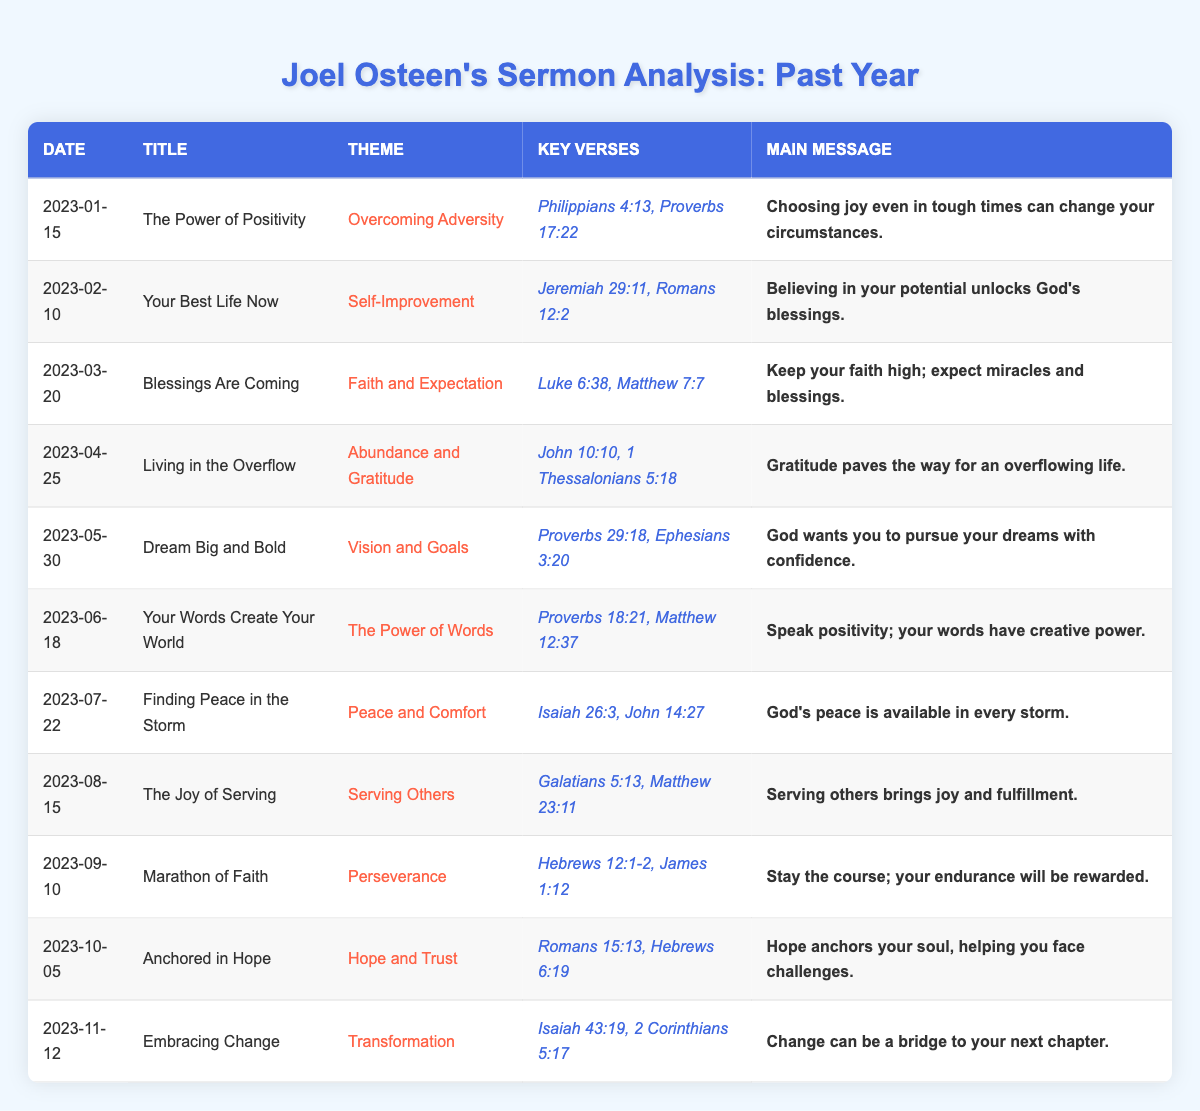What is the theme of the sermon titled "Finding Peace in the Storm"? The title "Finding Peace in the Storm" corresponds to the theme "Peace and Comfort" as listed in the table. To find the theme, I simply looked for the row that contains the sermon title in question.
Answer: Peace and Comfort How many sermons are focused on the theme of "Faith and Expectation"? There is one sermon that specifically addresses the theme "Faith and Expectation", which is titled "Blessings Are Coming." I checked each theme in the table and counted the occurrences.
Answer: 1 What are the key verses for the sermon "Dream Big and Bold"? The sermon "Dream Big and Bold" lists its key verses as "Proverbs 29:18, Ephesians 3:20." I looked at the row corresponding to this title and read the key verses directly.
Answer: Proverbs 29:18, Ephesians 3:20 Is there a sermon that addresses "Serving Others" and what is its main message? Yes, there is a sermon titled "The Joy of Serving" that addresses "Serving Others." Its main message is "Serving others brings joy and fulfillment." I found this by locating the row for the specific theme and reading the main message column.
Answer: Yes, the main message is "Serving others brings joy and fulfillment." Which month had the highest number of sermons? All ten months listed from January to October have one sermon each, and there is one additional sermon in November. Therefore, November is the only month with two sermons, making it the month with the highest number. I analyzed the count of sermons month by month to conclude that November stands out.
Answer: November What is the overall message conveyed through the sermons that focus on positivity and faith? The sermons titled "The Power of Positivity," "Blessings Are Coming," and "Your Words Create Your World" emphasize messages related to positivity and faith, such as choosing joy, expecting blessings, and the power of words. I reviewed these sermons and summarized their main messages to find a common theme of positivity and affirmation in faith.
Answer: Positivity and affirmation in faith Which sermon has the main message about gratitude? The sermon titled "Living in the Overflow" discusses the importance of gratitude, stating that "Gratitude paves the way for an overflowing life." By searching through the table for the main message about gratitude, I identified this sermon.
Answer: Living in the Overflow 